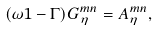<formula> <loc_0><loc_0><loc_500><loc_500>( \omega { 1 } - { \Gamma } ) { G } ^ { m n } _ { \eta } = { A } ^ { m n } _ { \eta } ,</formula> 